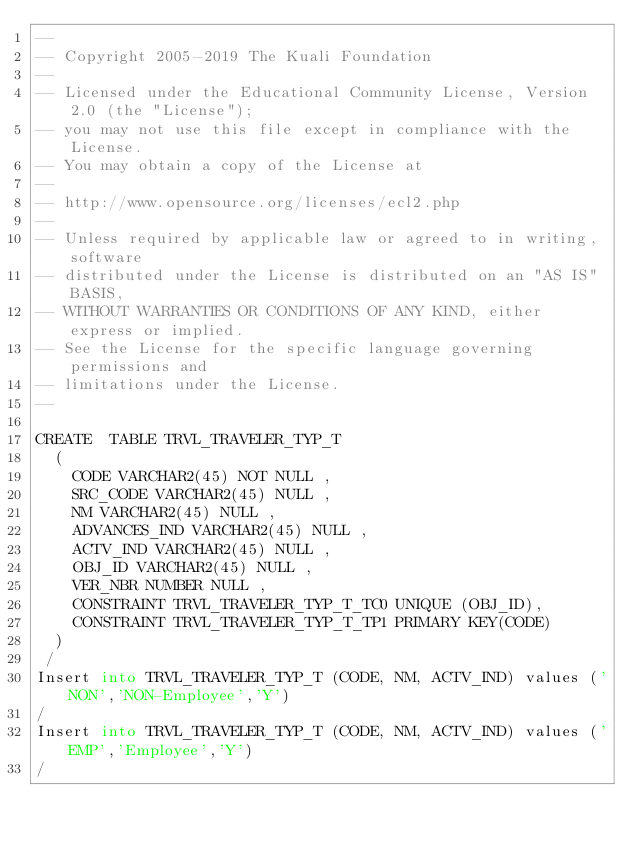Convert code to text. <code><loc_0><loc_0><loc_500><loc_500><_SQL_>--
-- Copyright 2005-2019 The Kuali Foundation
--
-- Licensed under the Educational Community License, Version 2.0 (the "License");
-- you may not use this file except in compliance with the License.
-- You may obtain a copy of the License at
--
-- http://www.opensource.org/licenses/ecl2.php
--
-- Unless required by applicable law or agreed to in writing, software
-- distributed under the License is distributed on an "AS IS" BASIS,
-- WITHOUT WARRANTIES OR CONDITIONS OF ANY KIND, either express or implied.
-- See the License for the specific language governing permissions and
-- limitations under the License.
--

CREATE  TABLE TRVL_TRAVELER_TYP_T
  (
    CODE VARCHAR2(45) NOT NULL ,
    SRC_CODE VARCHAR2(45) NULL ,
    NM VARCHAR2(45) NULL ,
    ADVANCES_IND VARCHAR2(45) NULL ,
    ACTV_IND VARCHAR2(45) NULL ,
    OBJ_ID VARCHAR2(45) NULL ,
    VER_NBR NUMBER NULL ,
    CONSTRAINT TRVL_TRAVELER_TYP_T_TC0 UNIQUE (OBJ_ID),
    CONSTRAINT TRVL_TRAVELER_TYP_T_TP1 PRIMARY KEY(CODE)
  )
 /
Insert into TRVL_TRAVELER_TYP_T (CODE, NM, ACTV_IND) values ('NON','NON-Employee','Y')
/
Insert into TRVL_TRAVELER_TYP_T (CODE, NM, ACTV_IND) values ('EMP','Employee','Y')
/</code> 